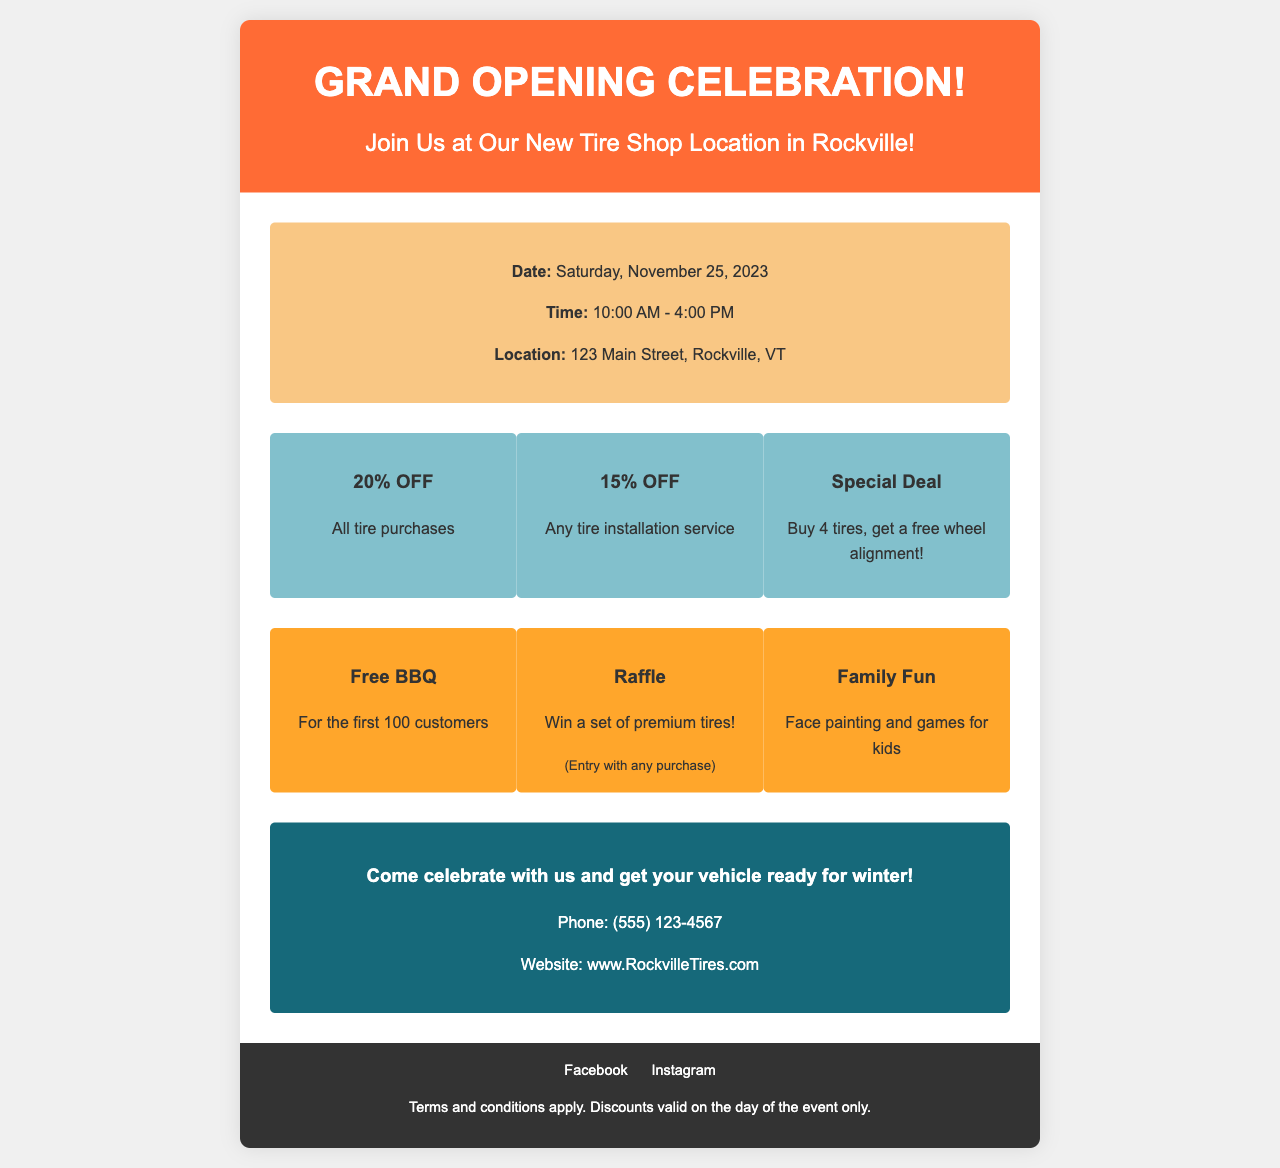What is the date of the grand opening celebration? The event date is explicitly stated in the event details section of the document.
Answer: Saturday, November 25, 2023 What time does the event start? The start time is provided in the event details section.
Answer: 10:00 AM What is the address of the new tire shop? The location is clearly mentioned in the event details.
Answer: 123 Main Street, Rockville, VT What discount is offered on tire installations? The discount for tire installation is listed in the discounts section.
Answer: 15% OFF What activity is available for the first 100 customers? The document specifies a free BBQ for the first 100 customers under activities.
Answer: Free BBQ How can customers win a set of premium tires? Winning a set of premium tires is explained in the activities section, specifying the way to enter.
Answer: Entry with any purchase What does the flyer suggest to prepare for winter? The call-to-action section suggests an action based on the upcoming season.
Answer: Get your vehicle ready for winter What type of document is this? The context and content indicate the purpose of this document.
Answer: Promotional flyer 